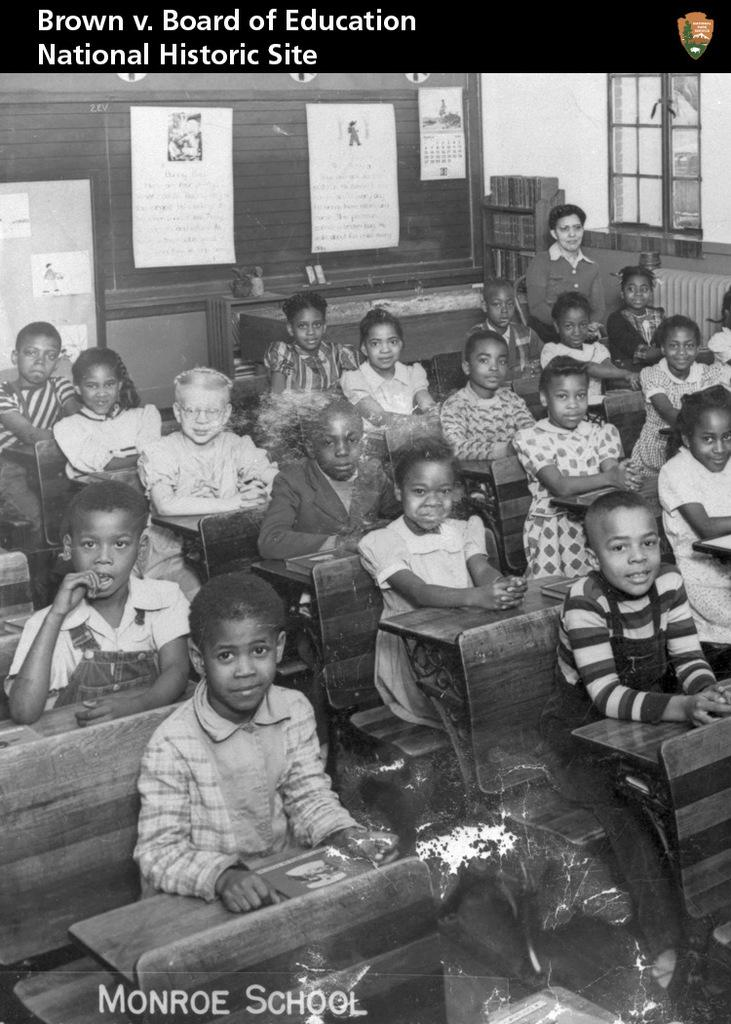What are the kids doing in the image? The kids are sitting on benches in the image. What can be seen on the benches? There are items placed on the benches. What is visible in the background of the image? There is a glass window and stickers visible in the background of the image. Can you describe any furniture in the image? Yes, there is a cupboard in the image. Are the kids having a fight with the umbrella in the image? There is no umbrella present in the image, and the kids are not fighting. 